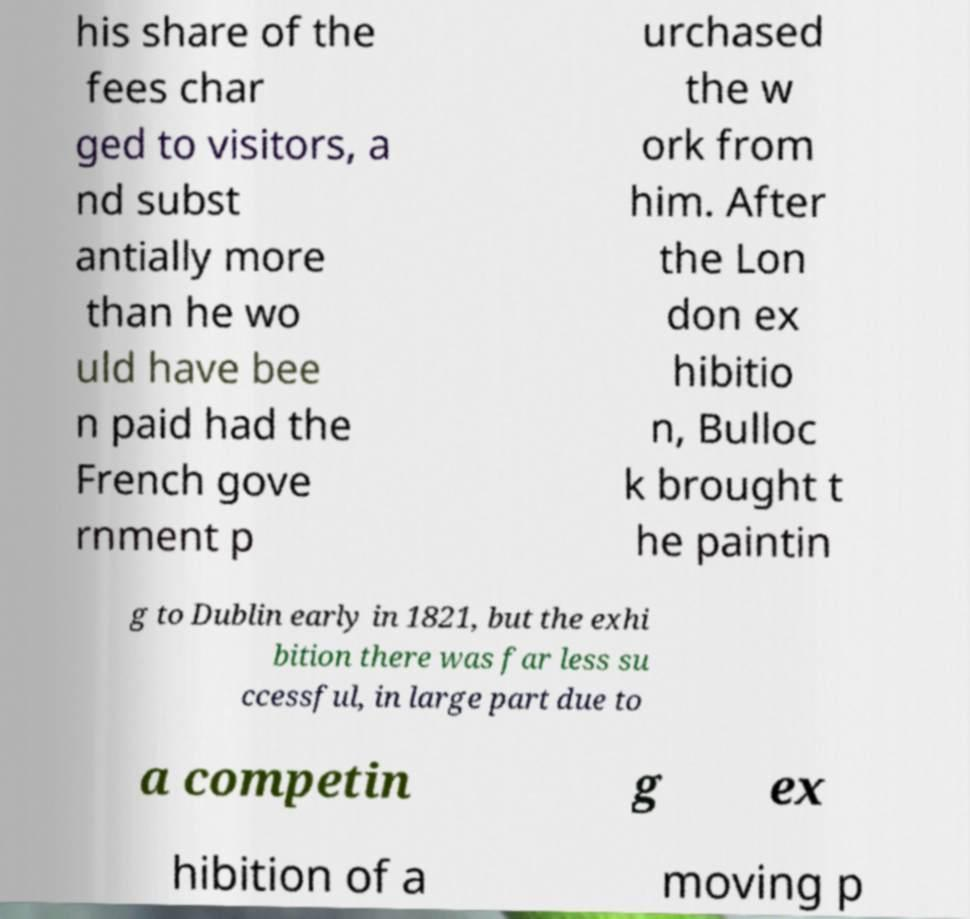What messages or text are displayed in this image? I need them in a readable, typed format. his share of the fees char ged to visitors, a nd subst antially more than he wo uld have bee n paid had the French gove rnment p urchased the w ork from him. After the Lon don ex hibitio n, Bulloc k brought t he paintin g to Dublin early in 1821, but the exhi bition there was far less su ccessful, in large part due to a competin g ex hibition of a moving p 